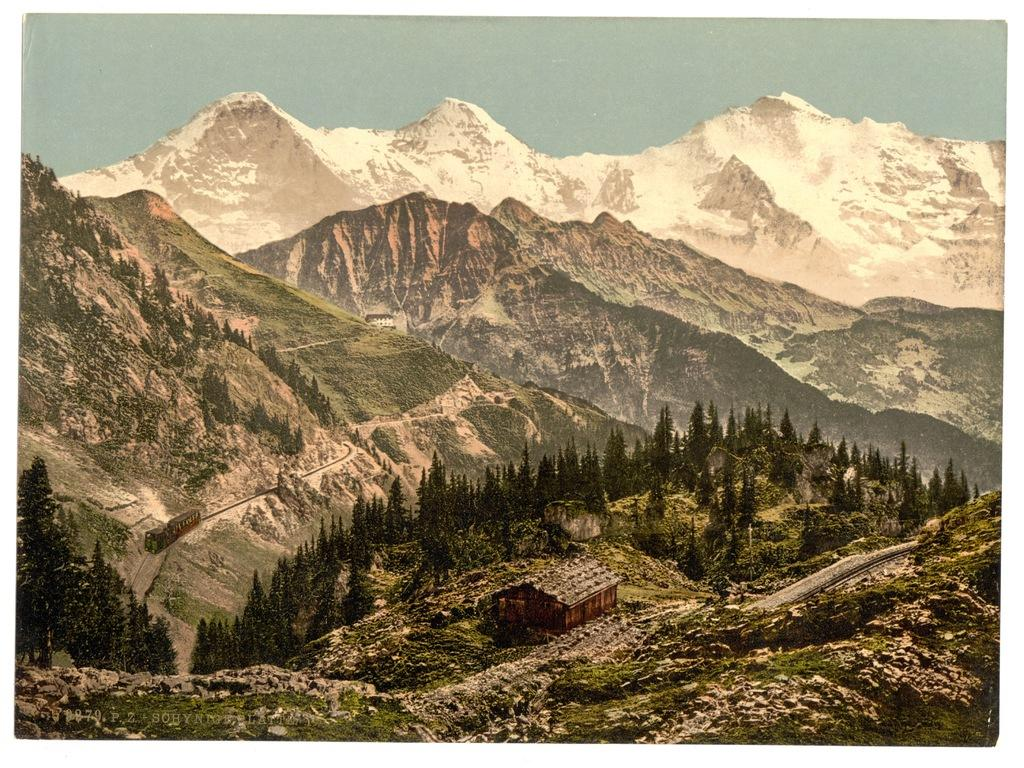What type of natural formation can be seen in the image? There are mountains in the image. What mode of transportation is present in the image? There is a train in the image. What type of vegetation is visible in the image? There are trees in the image. What type of structure is present in the image? There is a house in the image. What type of pathway is visible in the image? There is a road in the image. What type of ground cover is visible in the image? There is grass in the image. Is there any text or logo visible in the image? There is a watermark in the image. What part of the natural environment is visible in the image? The sky is visible in the image. Where is the girl playing with the stem in the image? There is no girl or stem present in the image. What type of soil can be seen in the image? The image does not show any soil, only grass, trees, and other elements. 